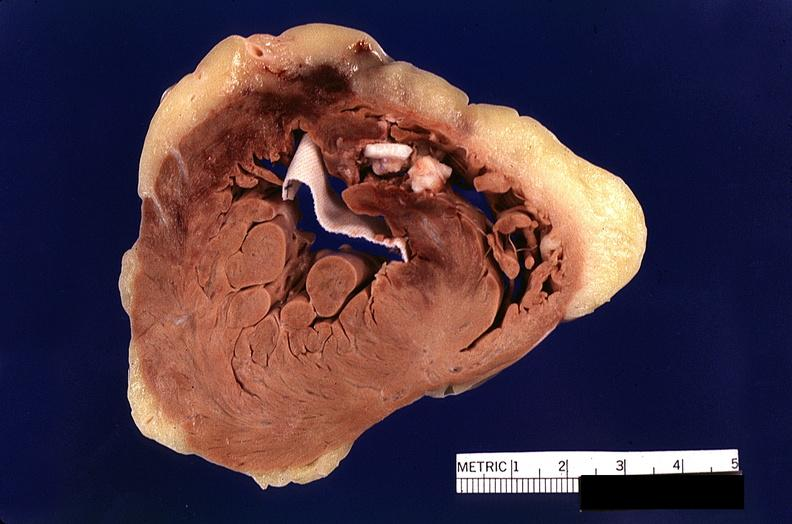does acute lymphocytic leukemia show heart, myocardial infarction, surgery to repair interventricular septum rupture?
Answer the question using a single word or phrase. No 